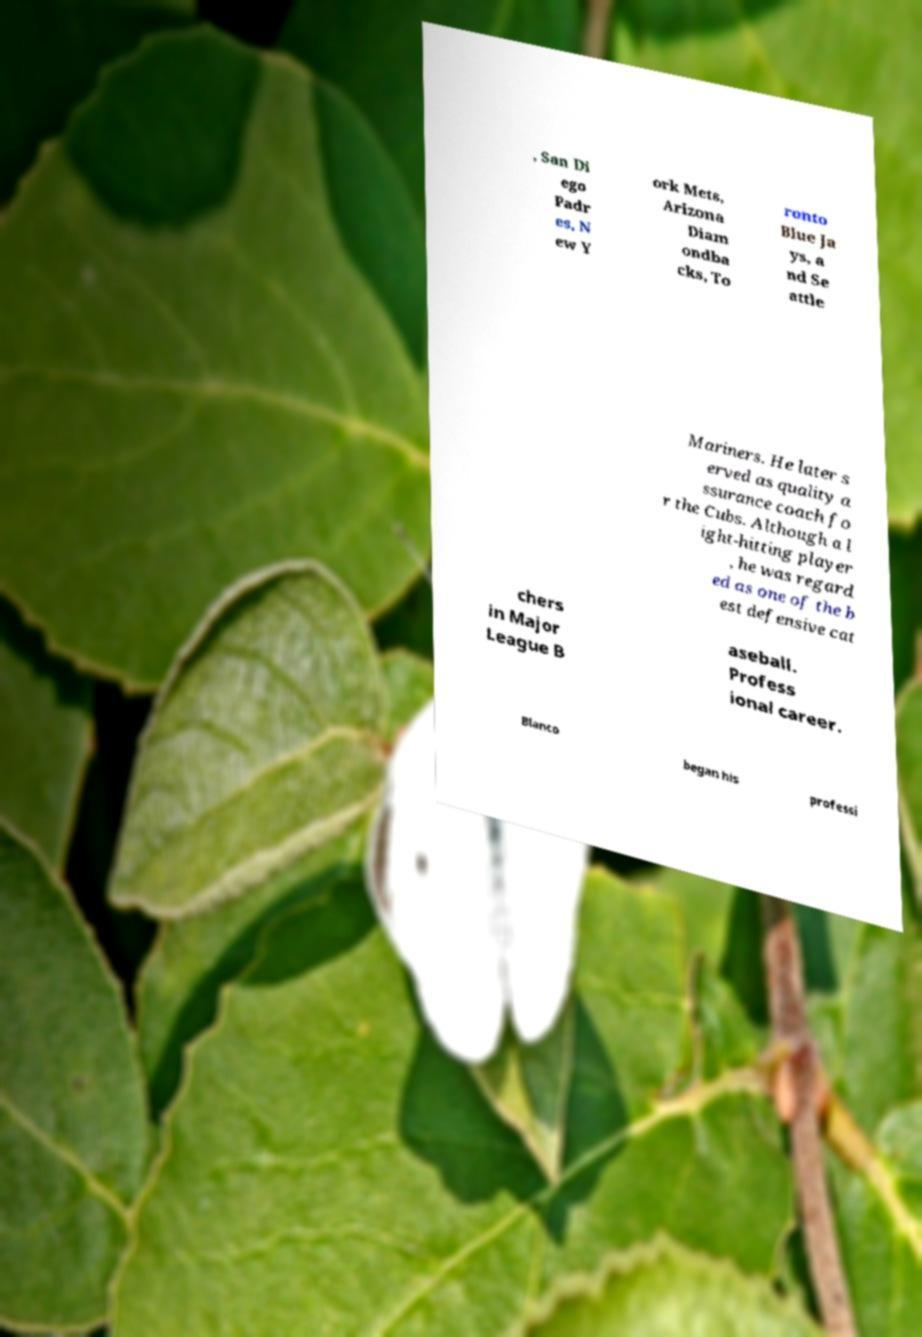What messages or text are displayed in this image? I need them in a readable, typed format. , San Di ego Padr es, N ew Y ork Mets, Arizona Diam ondba cks, To ronto Blue Ja ys, a nd Se attle Mariners. He later s erved as quality a ssurance coach fo r the Cubs. Although a l ight-hitting player , he was regard ed as one of the b est defensive cat chers in Major League B aseball. Profess ional career. Blanco began his professi 